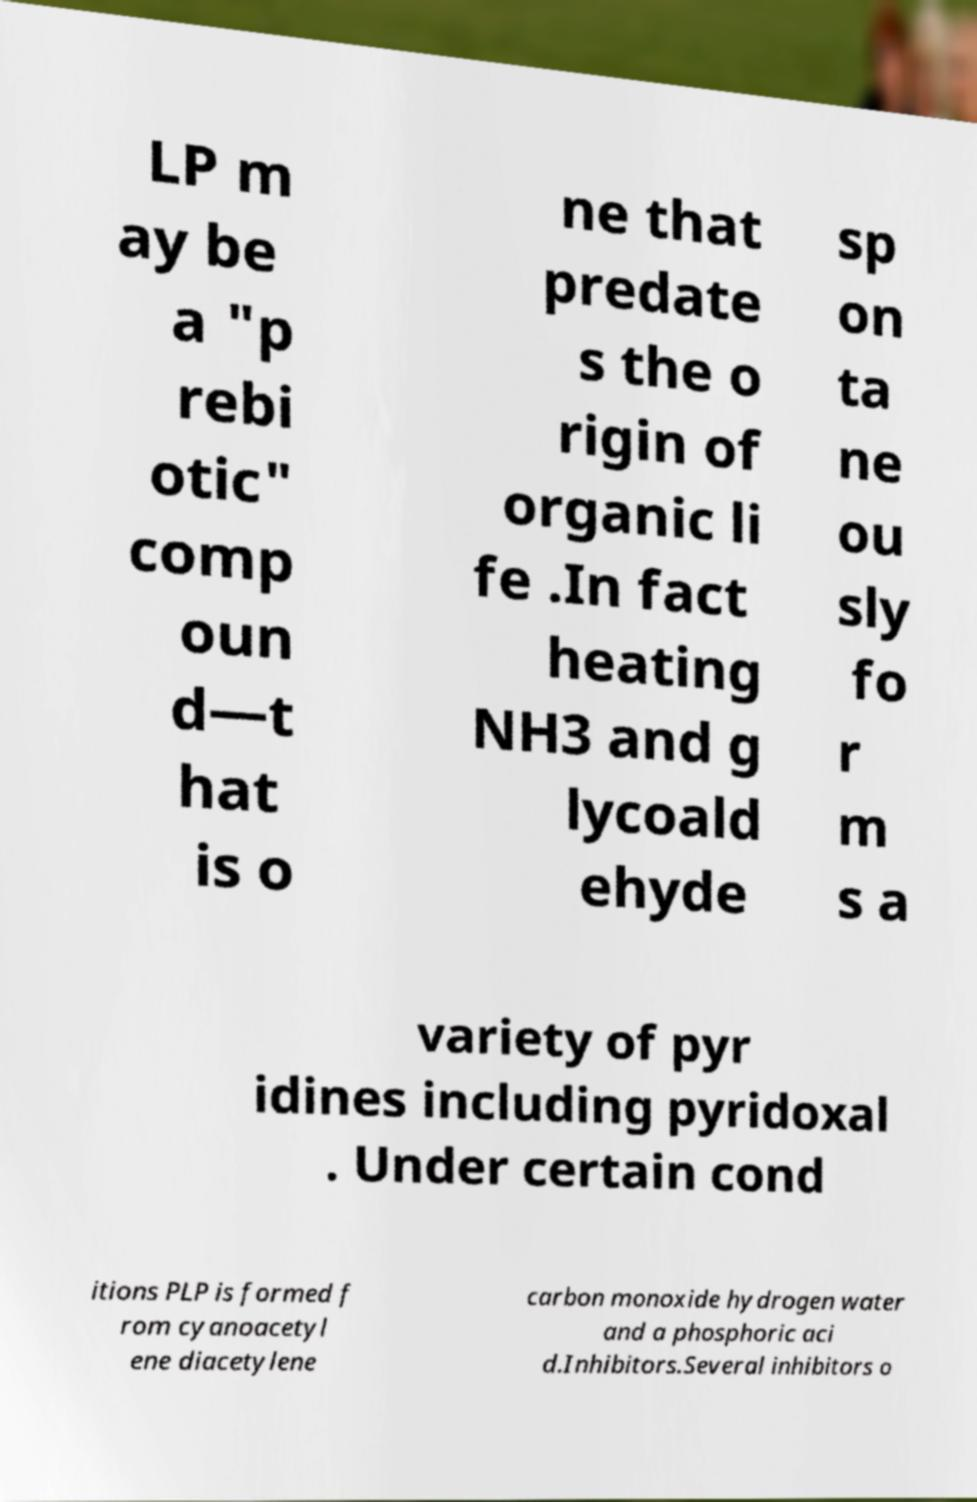Could you extract and type out the text from this image? LP m ay be a "p rebi otic" comp oun d—t hat is o ne that predate s the o rigin of organic li fe .In fact heating NH3 and g lycoald ehyde sp on ta ne ou sly fo r m s a variety of pyr idines including pyridoxal . Under certain cond itions PLP is formed f rom cyanoacetyl ene diacetylene carbon monoxide hydrogen water and a phosphoric aci d.Inhibitors.Several inhibitors o 